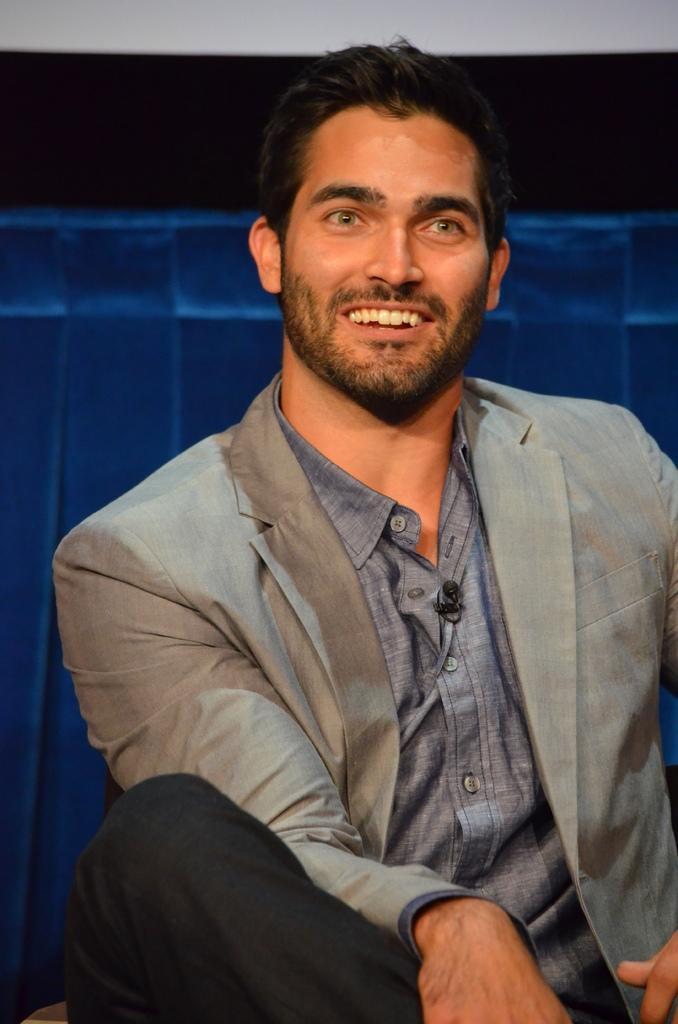In one or two sentences, can you explain what this image depicts? In the image there is a man smiling. And there is a mic on his shirt. Behind him there is a blue color object. 